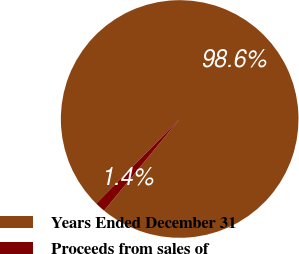<chart> <loc_0><loc_0><loc_500><loc_500><pie_chart><fcel>Years Ended December 31<fcel>Proceeds from sales of<nl><fcel>98.58%<fcel>1.42%<nl></chart> 